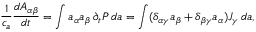<formula> <loc_0><loc_0><loc_500><loc_500>\frac { 1 } { c _ { a } } \frac { d A _ { \alpha \beta } } { d t } = \int a _ { \alpha } a _ { \beta } \, \partial _ { t } P \, d a = \int ( \delta _ { \alpha \gamma } a _ { \beta } + \delta _ { \beta \gamma } a _ { \alpha } ) J _ { \gamma } \, d a ,</formula> 